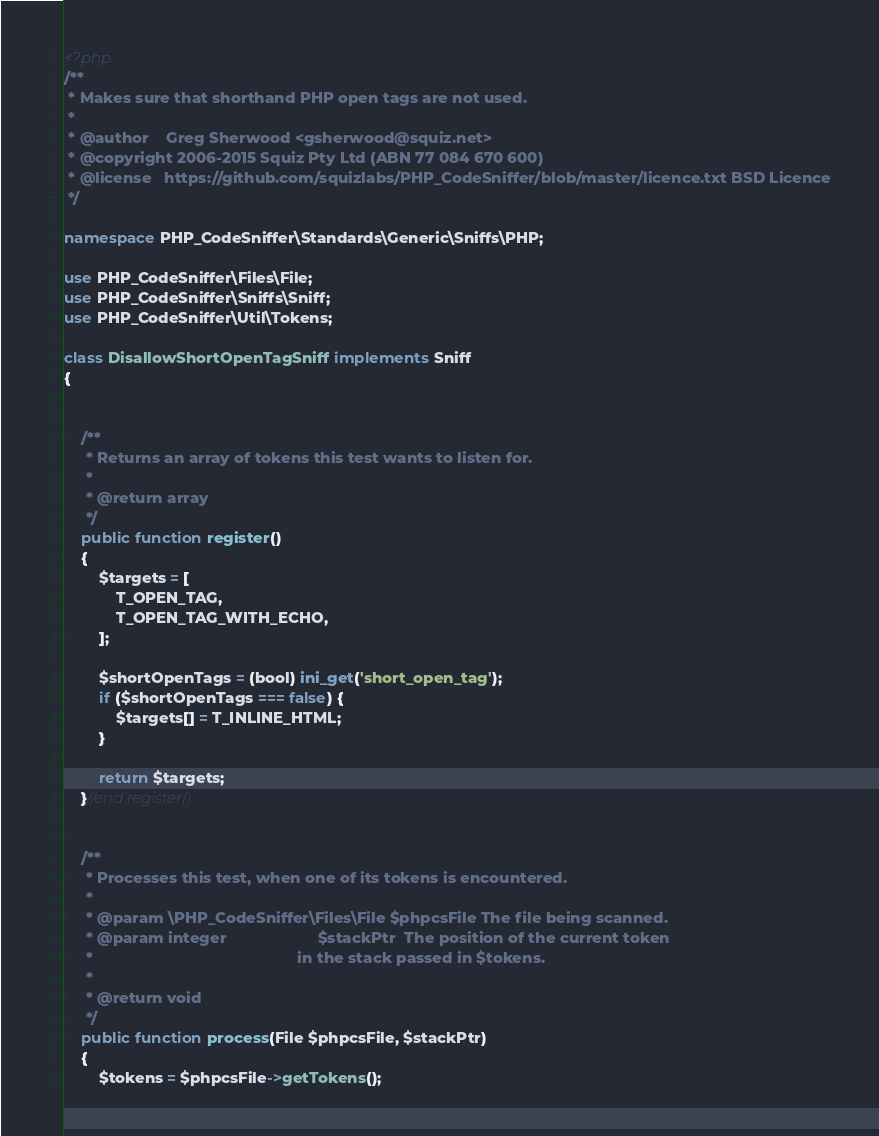Convert code to text. <code><loc_0><loc_0><loc_500><loc_500><_PHP_><?php
/**
 * Makes sure that shorthand PHP open tags are not used.
 *
 * @author    Greg Sherwood <gsherwood@squiz.net>
 * @copyright 2006-2015 Squiz Pty Ltd (ABN 77 084 670 600)
 * @license   https://github.com/squizlabs/PHP_CodeSniffer/blob/master/licence.txt BSD Licence
 */

namespace PHP_CodeSniffer\Standards\Generic\Sniffs\PHP;

use PHP_CodeSniffer\Files\File;
use PHP_CodeSniffer\Sniffs\Sniff;
use PHP_CodeSniffer\Util\Tokens;

class DisallowShortOpenTagSniff implements Sniff
{


    /**
     * Returns an array of tokens this test wants to listen for.
     *
     * @return array
     */
    public function register()
    {
        $targets = [
            T_OPEN_TAG,
            T_OPEN_TAG_WITH_ECHO,
        ];

        $shortOpenTags = (bool) ini_get('short_open_tag');
        if ($shortOpenTags === false) {
            $targets[] = T_INLINE_HTML;
        }

        return $targets;
    }//end register()


    /**
     * Processes this test, when one of its tokens is encountered.
     *
     * @param \PHP_CodeSniffer\Files\File $phpcsFile The file being scanned.
     * @param integer                     $stackPtr  The position of the current token
     *                                               in the stack passed in $tokens.
     *
     * @return void
     */
    public function process(File $phpcsFile, $stackPtr)
    {
        $tokens = $phpcsFile->getTokens();</code> 